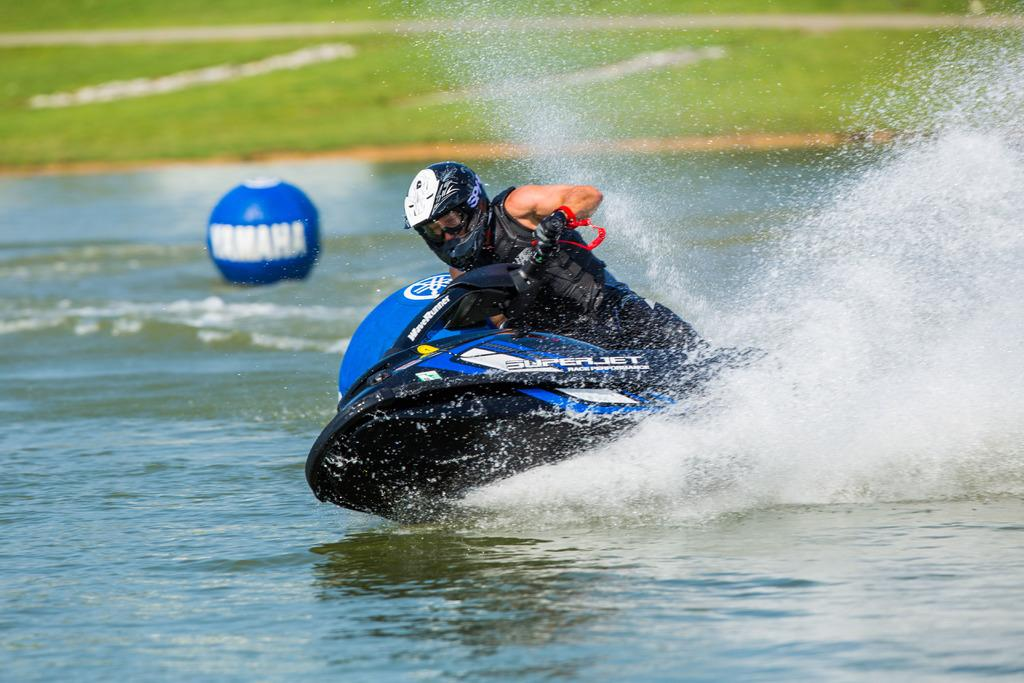Who is the person in the image? There is a man in the image. What protective gear is the man wearing? The man is wearing a helmet. What type of clothing is the man wearing? The man is wearing a jacket and trousers. What activity is the man engaged in? The man is riding a jet-ski. Where is the jet-ski located? The jet-ski is on the water. What can be seen in the background of the image? There is green grass visible in the background of the image. How many rings does the man have on his finger in the image? There is no mention of rings in the image, so it is impossible to determine how many rings the man is wearing. 